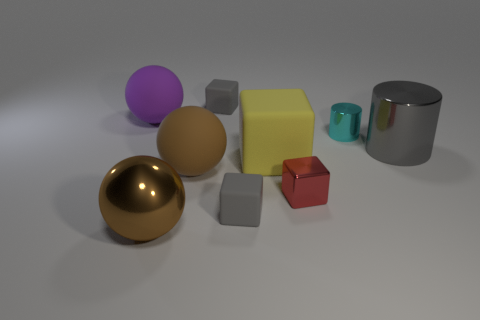Subtract all red spheres. How many gray blocks are left? 2 Subtract all tiny red shiny blocks. How many blocks are left? 3 Subtract 1 spheres. How many spheres are left? 2 Subtract all yellow cubes. How many cubes are left? 3 Subtract all blue blocks. Subtract all red balls. How many blocks are left? 4 Add 1 brown rubber spheres. How many objects exist? 10 Subtract all cylinders. How many objects are left? 7 Subtract 1 purple spheres. How many objects are left? 8 Subtract all large purple balls. Subtract all large brown rubber things. How many objects are left? 7 Add 4 small cyan cylinders. How many small cyan cylinders are left? 5 